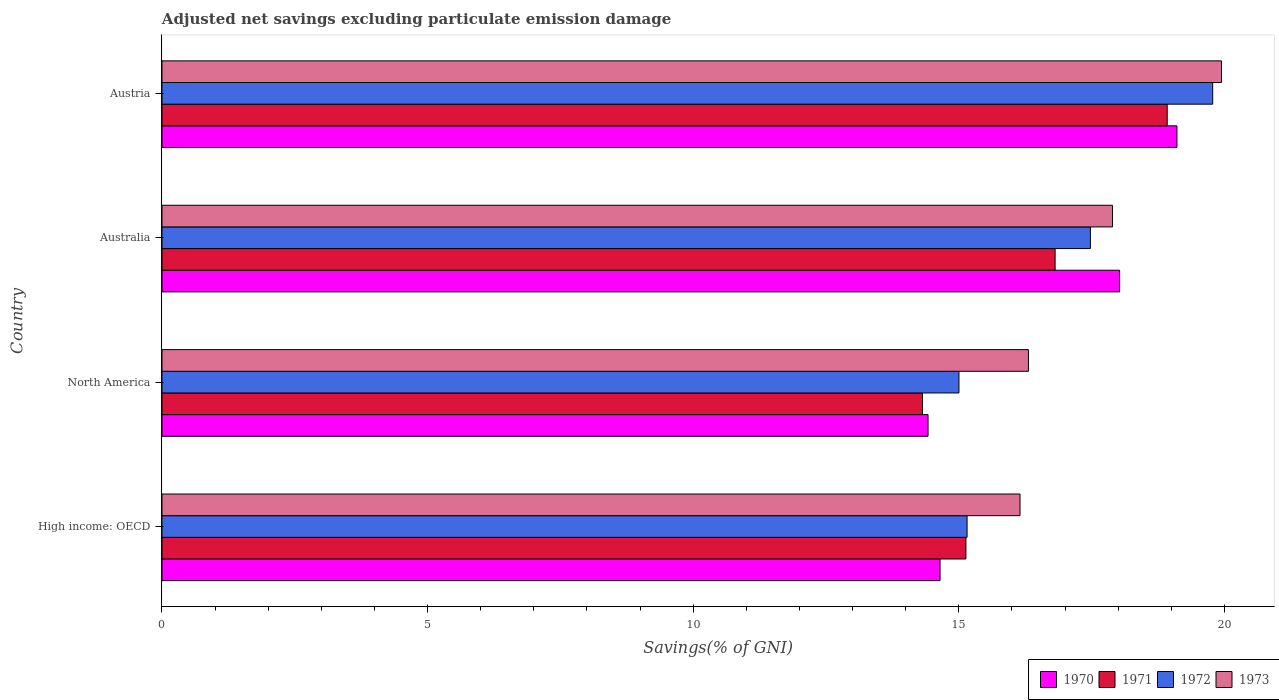How many different coloured bars are there?
Provide a short and direct response. 4. How many groups of bars are there?
Your answer should be compact. 4. Are the number of bars on each tick of the Y-axis equal?
Offer a terse response. Yes. In how many cases, is the number of bars for a given country not equal to the number of legend labels?
Offer a very short reply. 0. What is the adjusted net savings in 1971 in Austria?
Offer a terse response. 18.92. Across all countries, what is the maximum adjusted net savings in 1973?
Make the answer very short. 19.94. Across all countries, what is the minimum adjusted net savings in 1972?
Offer a very short reply. 15. In which country was the adjusted net savings in 1973 maximum?
Offer a terse response. Austria. In which country was the adjusted net savings in 1973 minimum?
Ensure brevity in your answer.  High income: OECD. What is the total adjusted net savings in 1970 in the graph?
Provide a succinct answer. 66.2. What is the difference between the adjusted net savings in 1973 in Austria and that in High income: OECD?
Give a very brief answer. 3.79. What is the difference between the adjusted net savings in 1970 in Austria and the adjusted net savings in 1973 in High income: OECD?
Provide a succinct answer. 2.95. What is the average adjusted net savings in 1970 per country?
Give a very brief answer. 16.55. What is the difference between the adjusted net savings in 1970 and adjusted net savings in 1973 in North America?
Give a very brief answer. -1.89. In how many countries, is the adjusted net savings in 1971 greater than 14 %?
Your answer should be very brief. 4. What is the ratio of the adjusted net savings in 1972 in Australia to that in Austria?
Provide a short and direct response. 0.88. Is the difference between the adjusted net savings in 1970 in Austria and High income: OECD greater than the difference between the adjusted net savings in 1973 in Austria and High income: OECD?
Offer a very short reply. Yes. What is the difference between the highest and the second highest adjusted net savings in 1970?
Provide a short and direct response. 1.08. What is the difference between the highest and the lowest adjusted net savings in 1973?
Keep it short and to the point. 3.79. What does the 3rd bar from the bottom in North America represents?
Offer a very short reply. 1972. Is it the case that in every country, the sum of the adjusted net savings in 1973 and adjusted net savings in 1970 is greater than the adjusted net savings in 1972?
Your response must be concise. Yes. How many bars are there?
Keep it short and to the point. 16. Are the values on the major ticks of X-axis written in scientific E-notation?
Give a very brief answer. No. Does the graph contain any zero values?
Provide a succinct answer. No. Where does the legend appear in the graph?
Give a very brief answer. Bottom right. How many legend labels are there?
Provide a short and direct response. 4. How are the legend labels stacked?
Provide a short and direct response. Horizontal. What is the title of the graph?
Make the answer very short. Adjusted net savings excluding particulate emission damage. Does "2009" appear as one of the legend labels in the graph?
Make the answer very short. No. What is the label or title of the X-axis?
Your response must be concise. Savings(% of GNI). What is the Savings(% of GNI) of 1970 in High income: OECD?
Offer a terse response. 14.65. What is the Savings(% of GNI) in 1971 in High income: OECD?
Your answer should be very brief. 15.13. What is the Savings(% of GNI) in 1972 in High income: OECD?
Provide a short and direct response. 15.15. What is the Savings(% of GNI) of 1973 in High income: OECD?
Your answer should be very brief. 16.15. What is the Savings(% of GNI) in 1970 in North America?
Your answer should be compact. 14.42. What is the Savings(% of GNI) of 1971 in North America?
Provide a succinct answer. 14.31. What is the Savings(% of GNI) in 1972 in North America?
Offer a very short reply. 15. What is the Savings(% of GNI) of 1973 in North America?
Offer a terse response. 16.31. What is the Savings(% of GNI) of 1970 in Australia?
Provide a succinct answer. 18.03. What is the Savings(% of GNI) of 1971 in Australia?
Keep it short and to the point. 16.81. What is the Savings(% of GNI) in 1972 in Australia?
Your answer should be compact. 17.48. What is the Savings(% of GNI) of 1973 in Australia?
Keep it short and to the point. 17.89. What is the Savings(% of GNI) of 1970 in Austria?
Your response must be concise. 19.11. What is the Savings(% of GNI) of 1971 in Austria?
Keep it short and to the point. 18.92. What is the Savings(% of GNI) of 1972 in Austria?
Give a very brief answer. 19.78. What is the Savings(% of GNI) of 1973 in Austria?
Offer a terse response. 19.94. Across all countries, what is the maximum Savings(% of GNI) of 1970?
Provide a succinct answer. 19.11. Across all countries, what is the maximum Savings(% of GNI) in 1971?
Keep it short and to the point. 18.92. Across all countries, what is the maximum Savings(% of GNI) of 1972?
Your response must be concise. 19.78. Across all countries, what is the maximum Savings(% of GNI) of 1973?
Offer a terse response. 19.94. Across all countries, what is the minimum Savings(% of GNI) in 1970?
Give a very brief answer. 14.42. Across all countries, what is the minimum Savings(% of GNI) in 1971?
Your answer should be compact. 14.31. Across all countries, what is the minimum Savings(% of GNI) in 1972?
Keep it short and to the point. 15. Across all countries, what is the minimum Savings(% of GNI) of 1973?
Ensure brevity in your answer.  16.15. What is the total Savings(% of GNI) in 1970 in the graph?
Provide a short and direct response. 66.2. What is the total Savings(% of GNI) of 1971 in the graph?
Offer a terse response. 65.18. What is the total Savings(% of GNI) in 1972 in the graph?
Provide a short and direct response. 67.41. What is the total Savings(% of GNI) in 1973 in the graph?
Give a very brief answer. 70.3. What is the difference between the Savings(% of GNI) of 1970 in High income: OECD and that in North America?
Your answer should be very brief. 0.23. What is the difference between the Savings(% of GNI) of 1971 in High income: OECD and that in North America?
Your response must be concise. 0.82. What is the difference between the Savings(% of GNI) of 1972 in High income: OECD and that in North America?
Your answer should be compact. 0.15. What is the difference between the Savings(% of GNI) in 1973 in High income: OECD and that in North America?
Your response must be concise. -0.16. What is the difference between the Savings(% of GNI) of 1970 in High income: OECD and that in Australia?
Keep it short and to the point. -3.38. What is the difference between the Savings(% of GNI) in 1971 in High income: OECD and that in Australia?
Offer a very short reply. -1.68. What is the difference between the Savings(% of GNI) of 1972 in High income: OECD and that in Australia?
Your answer should be very brief. -2.32. What is the difference between the Savings(% of GNI) in 1973 in High income: OECD and that in Australia?
Your answer should be compact. -1.74. What is the difference between the Savings(% of GNI) of 1970 in High income: OECD and that in Austria?
Give a very brief answer. -4.46. What is the difference between the Savings(% of GNI) of 1971 in High income: OECD and that in Austria?
Offer a terse response. -3.79. What is the difference between the Savings(% of GNI) of 1972 in High income: OECD and that in Austria?
Give a very brief answer. -4.62. What is the difference between the Savings(% of GNI) of 1973 in High income: OECD and that in Austria?
Your answer should be compact. -3.79. What is the difference between the Savings(% of GNI) in 1970 in North America and that in Australia?
Provide a succinct answer. -3.61. What is the difference between the Savings(% of GNI) in 1971 in North America and that in Australia?
Keep it short and to the point. -2.5. What is the difference between the Savings(% of GNI) in 1972 in North America and that in Australia?
Provide a short and direct response. -2.47. What is the difference between the Savings(% of GNI) of 1973 in North America and that in Australia?
Offer a very short reply. -1.58. What is the difference between the Savings(% of GNI) in 1970 in North America and that in Austria?
Offer a terse response. -4.69. What is the difference between the Savings(% of GNI) in 1971 in North America and that in Austria?
Your answer should be compact. -4.61. What is the difference between the Savings(% of GNI) in 1972 in North America and that in Austria?
Your response must be concise. -4.78. What is the difference between the Savings(% of GNI) in 1973 in North America and that in Austria?
Offer a terse response. -3.63. What is the difference between the Savings(% of GNI) in 1970 in Australia and that in Austria?
Your response must be concise. -1.08. What is the difference between the Savings(% of GNI) in 1971 in Australia and that in Austria?
Provide a succinct answer. -2.11. What is the difference between the Savings(% of GNI) of 1972 in Australia and that in Austria?
Your answer should be very brief. -2.3. What is the difference between the Savings(% of GNI) in 1973 in Australia and that in Austria?
Provide a succinct answer. -2.05. What is the difference between the Savings(% of GNI) in 1970 in High income: OECD and the Savings(% of GNI) in 1971 in North America?
Provide a succinct answer. 0.33. What is the difference between the Savings(% of GNI) in 1970 in High income: OECD and the Savings(% of GNI) in 1972 in North America?
Keep it short and to the point. -0.36. What is the difference between the Savings(% of GNI) of 1970 in High income: OECD and the Savings(% of GNI) of 1973 in North America?
Offer a very short reply. -1.66. What is the difference between the Savings(% of GNI) in 1971 in High income: OECD and the Savings(% of GNI) in 1972 in North America?
Keep it short and to the point. 0.13. What is the difference between the Savings(% of GNI) in 1971 in High income: OECD and the Savings(% of GNI) in 1973 in North America?
Your answer should be compact. -1.18. What is the difference between the Savings(% of GNI) of 1972 in High income: OECD and the Savings(% of GNI) of 1973 in North America?
Provide a succinct answer. -1.15. What is the difference between the Savings(% of GNI) in 1970 in High income: OECD and the Savings(% of GNI) in 1971 in Australia?
Your answer should be compact. -2.17. What is the difference between the Savings(% of GNI) in 1970 in High income: OECD and the Savings(% of GNI) in 1972 in Australia?
Give a very brief answer. -2.83. What is the difference between the Savings(% of GNI) of 1970 in High income: OECD and the Savings(% of GNI) of 1973 in Australia?
Provide a short and direct response. -3.25. What is the difference between the Savings(% of GNI) of 1971 in High income: OECD and the Savings(% of GNI) of 1972 in Australia?
Make the answer very short. -2.34. What is the difference between the Savings(% of GNI) of 1971 in High income: OECD and the Savings(% of GNI) of 1973 in Australia?
Your answer should be very brief. -2.76. What is the difference between the Savings(% of GNI) in 1972 in High income: OECD and the Savings(% of GNI) in 1973 in Australia?
Make the answer very short. -2.74. What is the difference between the Savings(% of GNI) of 1970 in High income: OECD and the Savings(% of GNI) of 1971 in Austria?
Make the answer very short. -4.28. What is the difference between the Savings(% of GNI) in 1970 in High income: OECD and the Savings(% of GNI) in 1972 in Austria?
Your answer should be very brief. -5.13. What is the difference between the Savings(% of GNI) in 1970 in High income: OECD and the Savings(% of GNI) in 1973 in Austria?
Give a very brief answer. -5.3. What is the difference between the Savings(% of GNI) in 1971 in High income: OECD and the Savings(% of GNI) in 1972 in Austria?
Your response must be concise. -4.64. What is the difference between the Savings(% of GNI) in 1971 in High income: OECD and the Savings(% of GNI) in 1973 in Austria?
Make the answer very short. -4.81. What is the difference between the Savings(% of GNI) in 1972 in High income: OECD and the Savings(% of GNI) in 1973 in Austria?
Your answer should be compact. -4.79. What is the difference between the Savings(% of GNI) in 1970 in North America and the Savings(% of GNI) in 1971 in Australia?
Provide a short and direct response. -2.39. What is the difference between the Savings(% of GNI) in 1970 in North America and the Savings(% of GNI) in 1972 in Australia?
Offer a terse response. -3.06. What is the difference between the Savings(% of GNI) in 1970 in North America and the Savings(% of GNI) in 1973 in Australia?
Your answer should be compact. -3.47. What is the difference between the Savings(% of GNI) of 1971 in North America and the Savings(% of GNI) of 1972 in Australia?
Offer a very short reply. -3.16. What is the difference between the Savings(% of GNI) of 1971 in North America and the Savings(% of GNI) of 1973 in Australia?
Your answer should be compact. -3.58. What is the difference between the Savings(% of GNI) of 1972 in North America and the Savings(% of GNI) of 1973 in Australia?
Offer a terse response. -2.89. What is the difference between the Savings(% of GNI) of 1970 in North America and the Savings(% of GNI) of 1971 in Austria?
Ensure brevity in your answer.  -4.5. What is the difference between the Savings(% of GNI) in 1970 in North America and the Savings(% of GNI) in 1972 in Austria?
Offer a very short reply. -5.36. What is the difference between the Savings(% of GNI) in 1970 in North America and the Savings(% of GNI) in 1973 in Austria?
Keep it short and to the point. -5.52. What is the difference between the Savings(% of GNI) in 1971 in North America and the Savings(% of GNI) in 1972 in Austria?
Your response must be concise. -5.46. What is the difference between the Savings(% of GNI) in 1971 in North America and the Savings(% of GNI) in 1973 in Austria?
Provide a short and direct response. -5.63. What is the difference between the Savings(% of GNI) of 1972 in North America and the Savings(% of GNI) of 1973 in Austria?
Make the answer very short. -4.94. What is the difference between the Savings(% of GNI) of 1970 in Australia and the Savings(% of GNI) of 1971 in Austria?
Give a very brief answer. -0.9. What is the difference between the Savings(% of GNI) of 1970 in Australia and the Savings(% of GNI) of 1972 in Austria?
Make the answer very short. -1.75. What is the difference between the Savings(% of GNI) in 1970 in Australia and the Savings(% of GNI) in 1973 in Austria?
Provide a short and direct response. -1.92. What is the difference between the Savings(% of GNI) in 1971 in Australia and the Savings(% of GNI) in 1972 in Austria?
Provide a succinct answer. -2.97. What is the difference between the Savings(% of GNI) in 1971 in Australia and the Savings(% of GNI) in 1973 in Austria?
Keep it short and to the point. -3.13. What is the difference between the Savings(% of GNI) of 1972 in Australia and the Savings(% of GNI) of 1973 in Austria?
Ensure brevity in your answer.  -2.47. What is the average Savings(% of GNI) in 1970 per country?
Keep it short and to the point. 16.55. What is the average Savings(% of GNI) in 1971 per country?
Offer a terse response. 16.3. What is the average Savings(% of GNI) of 1972 per country?
Your answer should be very brief. 16.85. What is the average Savings(% of GNI) in 1973 per country?
Your response must be concise. 17.57. What is the difference between the Savings(% of GNI) in 1970 and Savings(% of GNI) in 1971 in High income: OECD?
Offer a terse response. -0.49. What is the difference between the Savings(% of GNI) of 1970 and Savings(% of GNI) of 1972 in High income: OECD?
Keep it short and to the point. -0.51. What is the difference between the Savings(% of GNI) of 1970 and Savings(% of GNI) of 1973 in High income: OECD?
Your response must be concise. -1.51. What is the difference between the Savings(% of GNI) of 1971 and Savings(% of GNI) of 1972 in High income: OECD?
Keep it short and to the point. -0.02. What is the difference between the Savings(% of GNI) of 1971 and Savings(% of GNI) of 1973 in High income: OECD?
Offer a terse response. -1.02. What is the difference between the Savings(% of GNI) of 1972 and Savings(% of GNI) of 1973 in High income: OECD?
Ensure brevity in your answer.  -1. What is the difference between the Savings(% of GNI) in 1970 and Savings(% of GNI) in 1971 in North America?
Ensure brevity in your answer.  0.11. What is the difference between the Savings(% of GNI) in 1970 and Savings(% of GNI) in 1972 in North America?
Keep it short and to the point. -0.58. What is the difference between the Savings(% of GNI) of 1970 and Savings(% of GNI) of 1973 in North America?
Your response must be concise. -1.89. What is the difference between the Savings(% of GNI) in 1971 and Savings(% of GNI) in 1972 in North America?
Provide a short and direct response. -0.69. What is the difference between the Savings(% of GNI) of 1971 and Savings(% of GNI) of 1973 in North America?
Your answer should be very brief. -2. What is the difference between the Savings(% of GNI) in 1972 and Savings(% of GNI) in 1973 in North America?
Keep it short and to the point. -1.31. What is the difference between the Savings(% of GNI) in 1970 and Savings(% of GNI) in 1971 in Australia?
Offer a terse response. 1.21. What is the difference between the Savings(% of GNI) in 1970 and Savings(% of GNI) in 1972 in Australia?
Your answer should be compact. 0.55. What is the difference between the Savings(% of GNI) in 1970 and Savings(% of GNI) in 1973 in Australia?
Ensure brevity in your answer.  0.13. What is the difference between the Savings(% of GNI) in 1971 and Savings(% of GNI) in 1972 in Australia?
Offer a terse response. -0.66. What is the difference between the Savings(% of GNI) of 1971 and Savings(% of GNI) of 1973 in Australia?
Offer a terse response. -1.08. What is the difference between the Savings(% of GNI) in 1972 and Savings(% of GNI) in 1973 in Australia?
Provide a succinct answer. -0.42. What is the difference between the Savings(% of GNI) in 1970 and Savings(% of GNI) in 1971 in Austria?
Ensure brevity in your answer.  0.18. What is the difference between the Savings(% of GNI) of 1970 and Savings(% of GNI) of 1972 in Austria?
Your response must be concise. -0.67. What is the difference between the Savings(% of GNI) of 1970 and Savings(% of GNI) of 1973 in Austria?
Provide a short and direct response. -0.84. What is the difference between the Savings(% of GNI) in 1971 and Savings(% of GNI) in 1972 in Austria?
Provide a succinct answer. -0.86. What is the difference between the Savings(% of GNI) in 1971 and Savings(% of GNI) in 1973 in Austria?
Give a very brief answer. -1.02. What is the difference between the Savings(% of GNI) of 1972 and Savings(% of GNI) of 1973 in Austria?
Your response must be concise. -0.17. What is the ratio of the Savings(% of GNI) of 1970 in High income: OECD to that in North America?
Ensure brevity in your answer.  1.02. What is the ratio of the Savings(% of GNI) of 1971 in High income: OECD to that in North America?
Your answer should be very brief. 1.06. What is the ratio of the Savings(% of GNI) in 1972 in High income: OECD to that in North America?
Make the answer very short. 1.01. What is the ratio of the Savings(% of GNI) of 1973 in High income: OECD to that in North America?
Make the answer very short. 0.99. What is the ratio of the Savings(% of GNI) of 1970 in High income: OECD to that in Australia?
Your response must be concise. 0.81. What is the ratio of the Savings(% of GNI) of 1971 in High income: OECD to that in Australia?
Your response must be concise. 0.9. What is the ratio of the Savings(% of GNI) in 1972 in High income: OECD to that in Australia?
Keep it short and to the point. 0.87. What is the ratio of the Savings(% of GNI) in 1973 in High income: OECD to that in Australia?
Provide a short and direct response. 0.9. What is the ratio of the Savings(% of GNI) of 1970 in High income: OECD to that in Austria?
Make the answer very short. 0.77. What is the ratio of the Savings(% of GNI) in 1971 in High income: OECD to that in Austria?
Offer a very short reply. 0.8. What is the ratio of the Savings(% of GNI) of 1972 in High income: OECD to that in Austria?
Keep it short and to the point. 0.77. What is the ratio of the Savings(% of GNI) in 1973 in High income: OECD to that in Austria?
Keep it short and to the point. 0.81. What is the ratio of the Savings(% of GNI) of 1970 in North America to that in Australia?
Your answer should be compact. 0.8. What is the ratio of the Savings(% of GNI) in 1971 in North America to that in Australia?
Offer a terse response. 0.85. What is the ratio of the Savings(% of GNI) of 1972 in North America to that in Australia?
Keep it short and to the point. 0.86. What is the ratio of the Savings(% of GNI) in 1973 in North America to that in Australia?
Keep it short and to the point. 0.91. What is the ratio of the Savings(% of GNI) of 1970 in North America to that in Austria?
Provide a short and direct response. 0.75. What is the ratio of the Savings(% of GNI) in 1971 in North America to that in Austria?
Offer a very short reply. 0.76. What is the ratio of the Savings(% of GNI) in 1972 in North America to that in Austria?
Provide a succinct answer. 0.76. What is the ratio of the Savings(% of GNI) of 1973 in North America to that in Austria?
Ensure brevity in your answer.  0.82. What is the ratio of the Savings(% of GNI) of 1970 in Australia to that in Austria?
Your answer should be compact. 0.94. What is the ratio of the Savings(% of GNI) of 1971 in Australia to that in Austria?
Keep it short and to the point. 0.89. What is the ratio of the Savings(% of GNI) of 1972 in Australia to that in Austria?
Your response must be concise. 0.88. What is the ratio of the Savings(% of GNI) in 1973 in Australia to that in Austria?
Your response must be concise. 0.9. What is the difference between the highest and the second highest Savings(% of GNI) in 1970?
Ensure brevity in your answer.  1.08. What is the difference between the highest and the second highest Savings(% of GNI) of 1971?
Your answer should be compact. 2.11. What is the difference between the highest and the second highest Savings(% of GNI) of 1972?
Provide a succinct answer. 2.3. What is the difference between the highest and the second highest Savings(% of GNI) of 1973?
Your answer should be very brief. 2.05. What is the difference between the highest and the lowest Savings(% of GNI) of 1970?
Provide a short and direct response. 4.69. What is the difference between the highest and the lowest Savings(% of GNI) in 1971?
Your response must be concise. 4.61. What is the difference between the highest and the lowest Savings(% of GNI) of 1972?
Make the answer very short. 4.78. What is the difference between the highest and the lowest Savings(% of GNI) in 1973?
Your response must be concise. 3.79. 